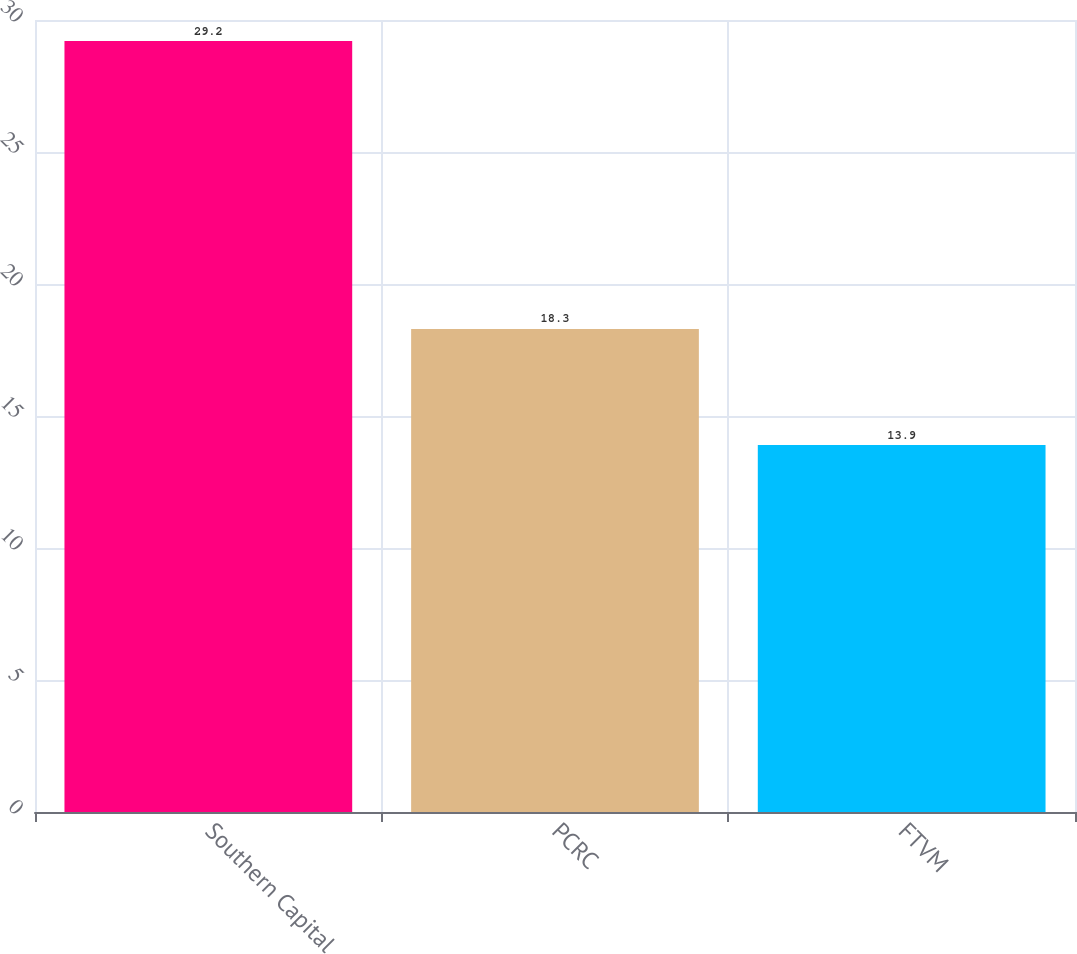Convert chart to OTSL. <chart><loc_0><loc_0><loc_500><loc_500><bar_chart><fcel>Southern Capital<fcel>PCRC<fcel>FTVM<nl><fcel>29.2<fcel>18.3<fcel>13.9<nl></chart> 